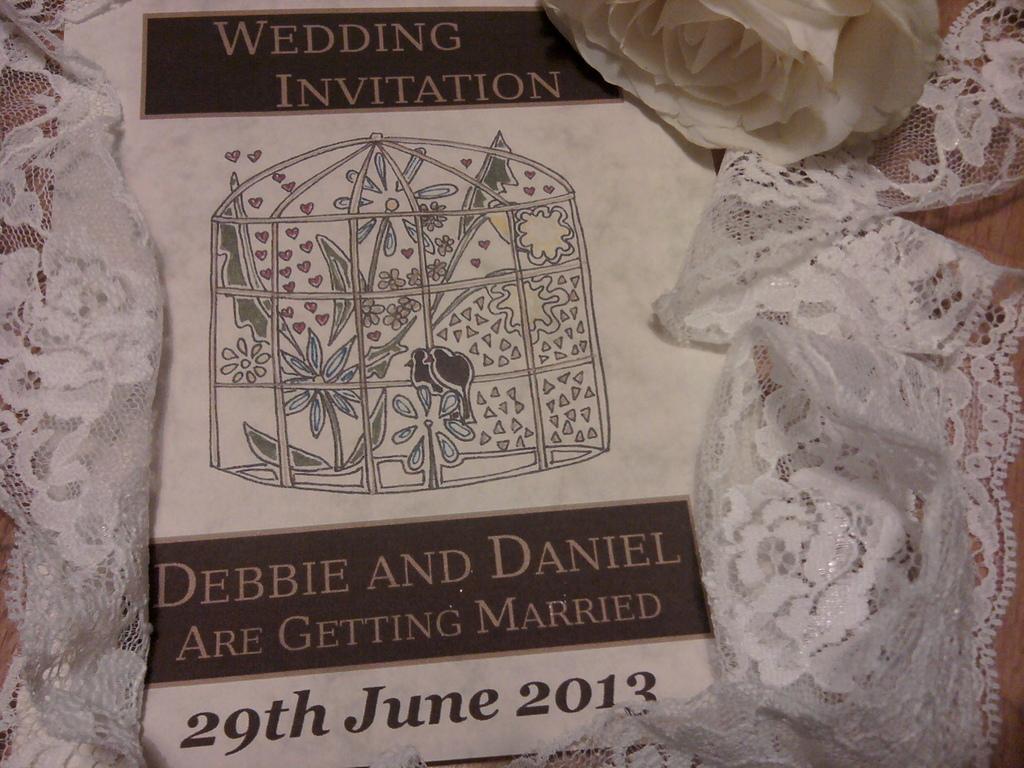Describe this image in one or two sentences. In this image we can see a white color pamphlet. Beside flower and cloth is present. 